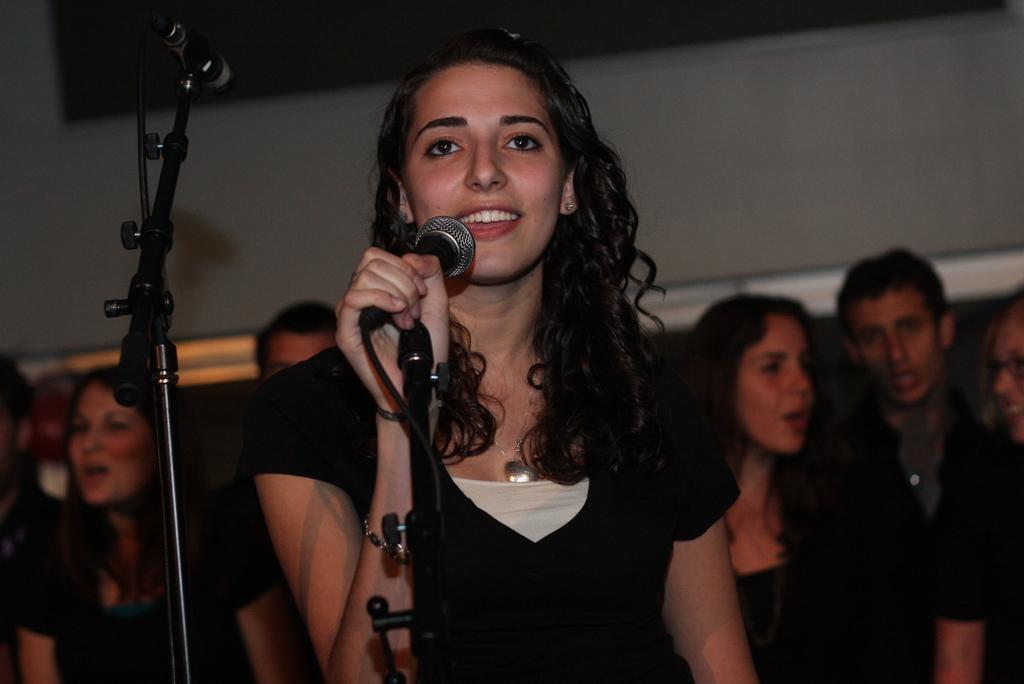Could you give a brief overview of what you see in this image? This woman wore black dress, holding mic and smiling. This is mic holder. At background there are persons. 